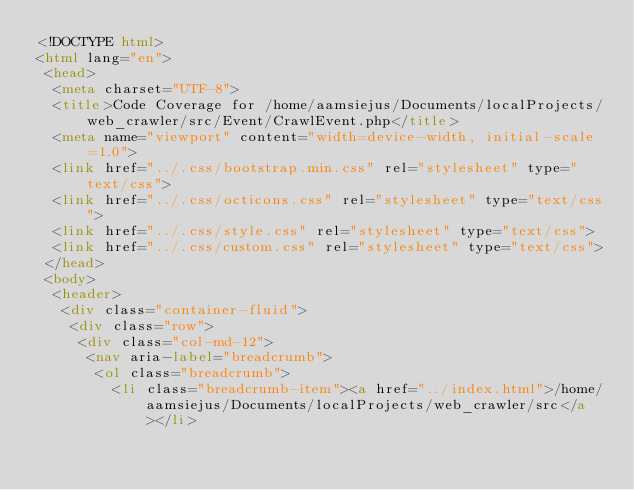<code> <loc_0><loc_0><loc_500><loc_500><_HTML_><!DOCTYPE html>
<html lang="en">
 <head>
  <meta charset="UTF-8">
  <title>Code Coverage for /home/aamsiejus/Documents/localProjects/web_crawler/src/Event/CrawlEvent.php</title>
  <meta name="viewport" content="width=device-width, initial-scale=1.0">
  <link href="../.css/bootstrap.min.css" rel="stylesheet" type="text/css">
  <link href="../.css/octicons.css" rel="stylesheet" type="text/css">
  <link href="../.css/style.css" rel="stylesheet" type="text/css">
  <link href="../.css/custom.css" rel="stylesheet" type="text/css">
 </head>
 <body>
  <header>
   <div class="container-fluid">
    <div class="row">
     <div class="col-md-12">
      <nav aria-label="breadcrumb">
       <ol class="breadcrumb">
         <li class="breadcrumb-item"><a href="../index.html">/home/aamsiejus/Documents/localProjects/web_crawler/src</a></li></code> 